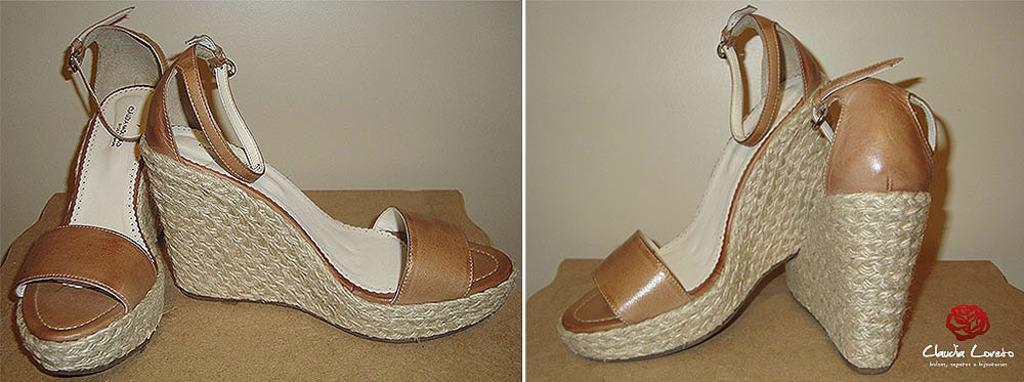What type of footwear can be seen on the floor in the images? There are two pairs of sandals on the floor in the images. What additional design element is present in the images? There is a logo present in the images. What type of written information is included in the images? There is text in the images. What can be seen behind the main subjects in the images? There is a wall visible in the background of the images. Based on the presence of a wall and floor, where might these images have been taken? The images are likely taken in a room. What type of cap is the writer wearing in the lunchroom? There is no cap, writer, or lunchroom present in the images; they only show two pairs of sandals, a logo, text, a wall, and a room setting. 